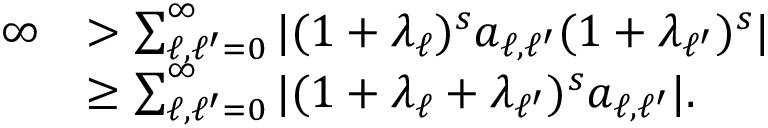<formula> <loc_0><loc_0><loc_500><loc_500>\begin{array} { r l } { \infty } & { > \sum _ { \ell , \ell ^ { \prime } = 0 } ^ { \infty } | ( 1 + \lambda _ { \ell } ) ^ { s } a _ { \ell , \ell ^ { \prime } } ( 1 + \lambda _ { \ell ^ { \prime } } ) ^ { s } | } \\ & { \geq \sum _ { \ell , \ell ^ { \prime } = 0 } ^ { \infty } | ( 1 + \lambda _ { \ell } + \lambda _ { \ell ^ { \prime } } ) ^ { s } a _ { \ell , \ell ^ { \prime } } | . } \end{array}</formula> 